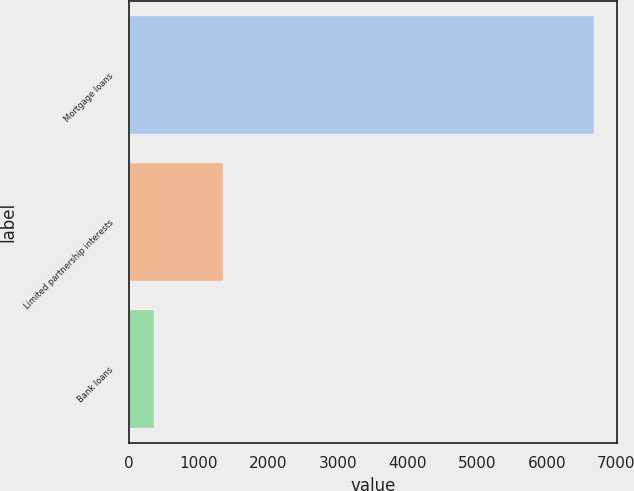<chart> <loc_0><loc_0><loc_500><loc_500><bar_chart><fcel>Mortgage loans<fcel>Limited partnership interests<fcel>Bank loans<nl><fcel>6679<fcel>1348<fcel>363<nl></chart> 